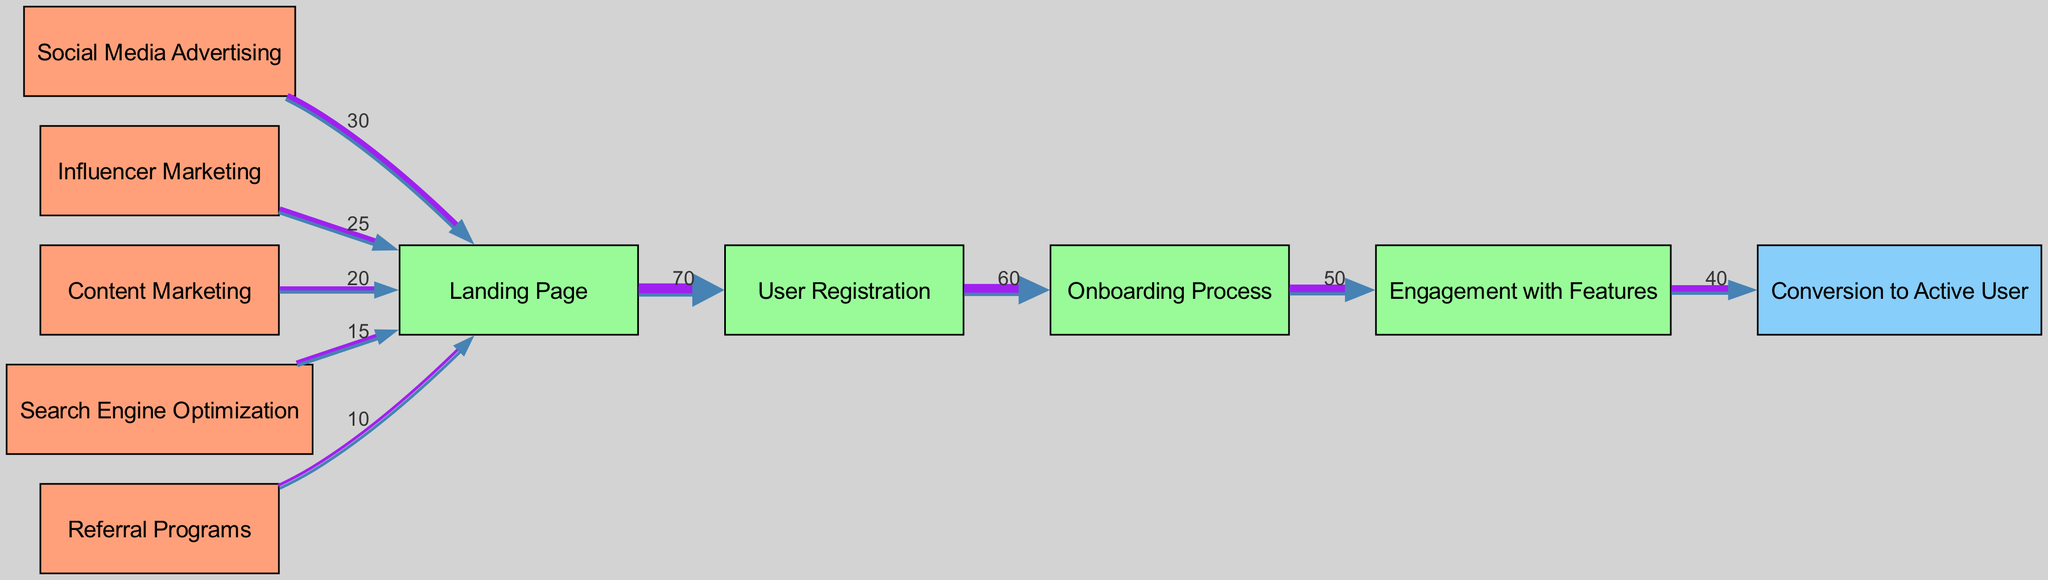What is the total flow of users from all source nodes to the Landing Page? To determine the total flow to the Landing Page, sum the values of all links connecting from source nodes to the Landing Page: 30 (Social Media Advertising) + 25 (Influencer Marketing) + 20 (Content Marketing) + 15 (Search Engine Optimization) + 10 (Referral Programs) = 100.
Answer: 100 Which interaction node receives the highest user flow? The interaction node that receives the highest user flow is the User Registration node. This can be seen from the link from the Landing Page to User Registration, which has the highest value of 70.
Answer: User Registration How many interaction nodes are present in the diagram? The diagram contains four interaction nodes: Landing Page, User Registration, Onboarding Process, and Engagement with Features. By counting these nodes in the diagram, we find there are four.
Answer: 4 What is the flow value from the Onboarding Process to the Engagement with Features? The flow value from the Onboarding Process to Engagement with Features is 50, as indicated by the direct link between these two nodes in the diagram.
Answer: 50 Which acquisition channel contributes the least user flow to the Landing Page? The acquisition channel that contributes the least user flow to the Landing Page is the Referral Programs, with a flow value of 10. This is the lowest value among the links to the Landing Page.
Answer: Referral Programs What is the percentage of users that convert to active users from the Engagement with Features? To find the percentage of users converting to active users, first note that 40 users convert from Engagement with Features. Given 50 users engage with the features, the percentage is (40/50) * 100 = 80%.
Answer: 80% How many total edges are present in the diagram? The total number of edges can be found by counting all the links connecting nodes in the diagram. There are a total of 8 edges present.
Answer: 8 What percentage of users moving from Landing Page to User Registration successfully complete the registration? The flow from Landing Page to User Registration is 70, with the next flow from User Registration to Onboarding Process being 60. To find the percentage, calculate (60/70) * 100 = 85.71%, which rounds to 86%.
Answer: 86% 